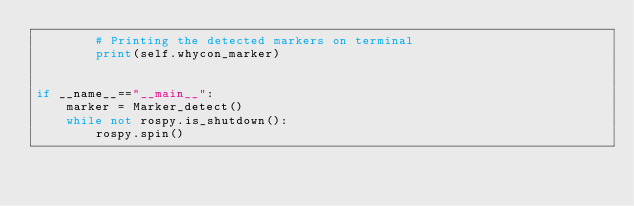<code> <loc_0><loc_0><loc_500><loc_500><_Python_>		# Printing the detected markers on terminal
		print(self.whycon_marker)


if __name__=="__main__":
	marker = Marker_detect()
	while not rospy.is_shutdown():
		rospy.spin()</code> 